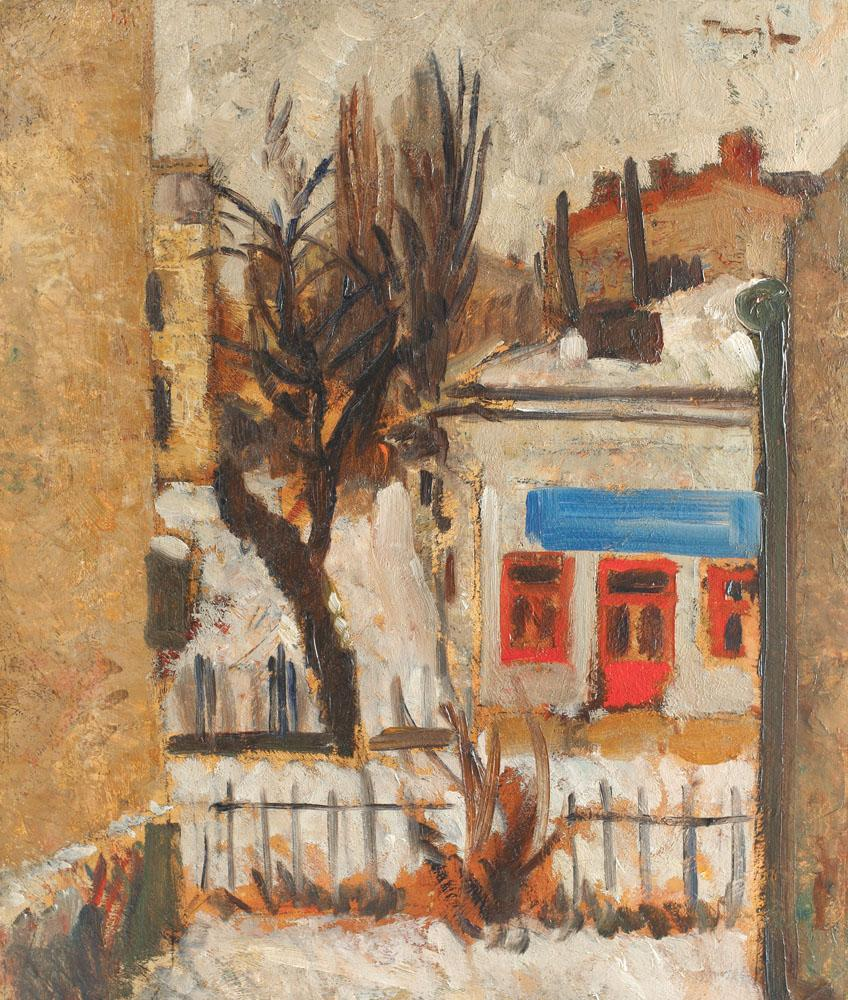What are the key elements in this picture? This striking impressionist painting reveals a scene awash with the subtle charm of a quiet urban side street. The key elements include a robust yet leafless tree to the left whose branches reach out towards the center, casting intricate shadows and lines across the view. Behind the tree is a rustic building with a vivid red window, a color echoed nowhere else in the composition and thus drawing the eye. To the right stands an elegant lamppost, its shape mirroring the vertical lines of the tree. The artist utilizes a rich palette of earth tones that suggest the texture of the urban landscape and possibly the chill of a late autumn or winter day. Despite the absence of human figures, the painting pulses with the life of the city, the play of light and shadow offering a narrative of early morning hours when the world stirs softly into motion. 